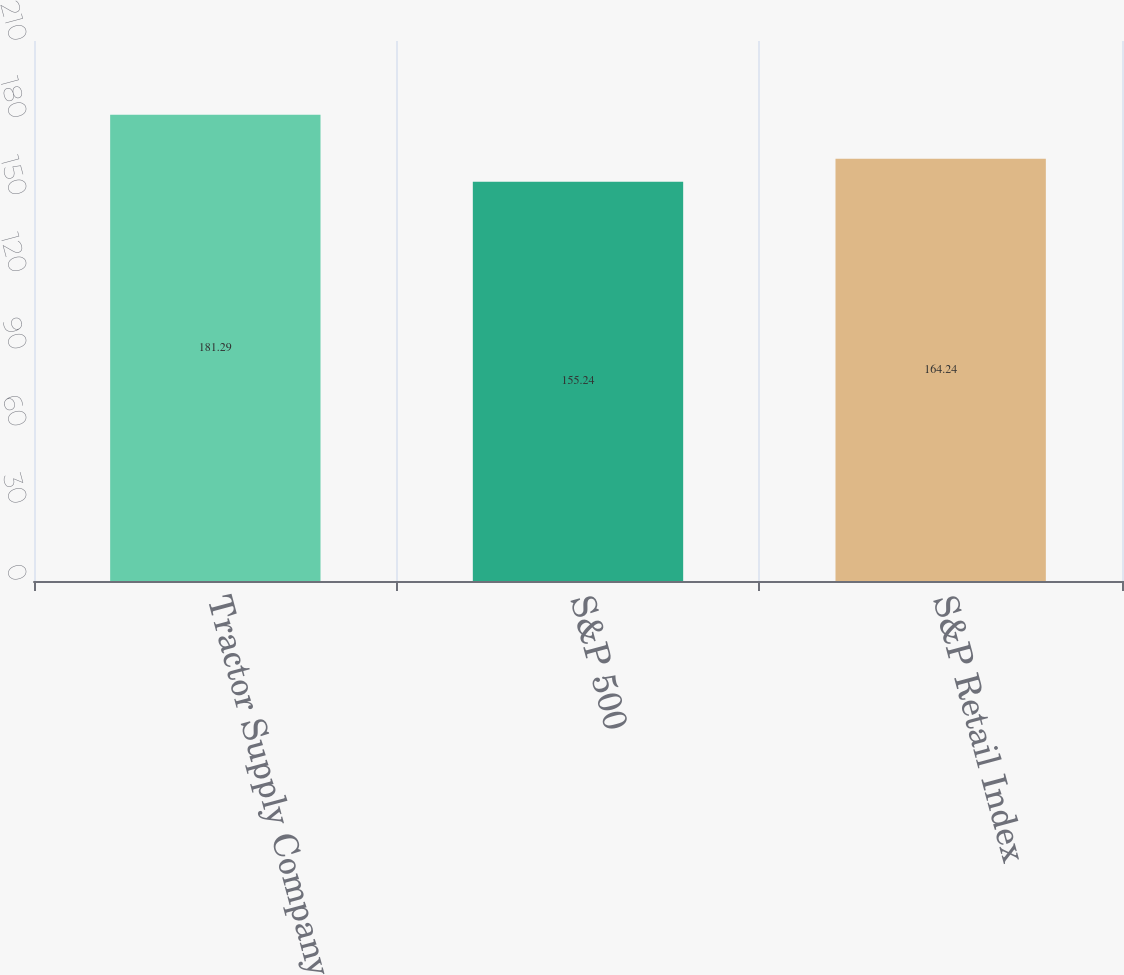Convert chart. <chart><loc_0><loc_0><loc_500><loc_500><bar_chart><fcel>Tractor Supply Company<fcel>S&P 500<fcel>S&P Retail Index<nl><fcel>181.29<fcel>155.24<fcel>164.24<nl></chart> 